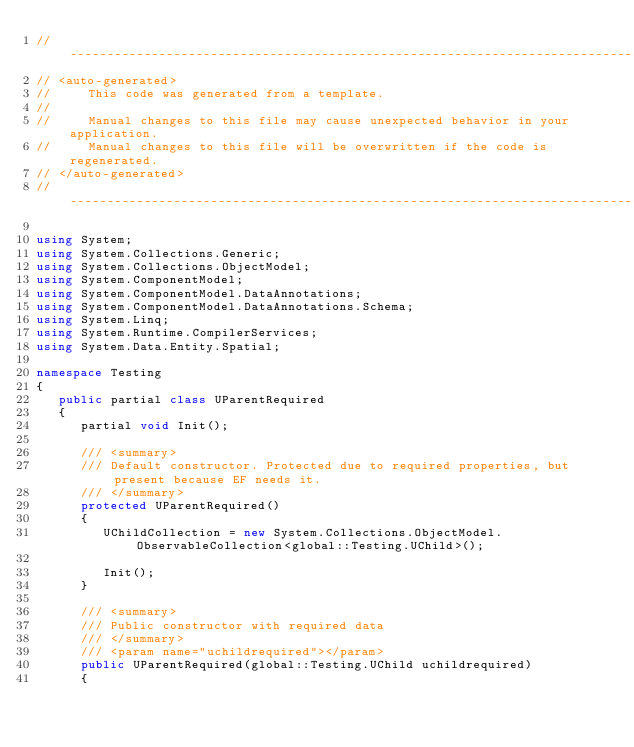<code> <loc_0><loc_0><loc_500><loc_500><_C#_>//------------------------------------------------------------------------------
// <auto-generated>
//     This code was generated from a template.
//
//     Manual changes to this file may cause unexpected behavior in your application.
//     Manual changes to this file will be overwritten if the code is regenerated.
// </auto-generated>
//------------------------------------------------------------------------------

using System;
using System.Collections.Generic;
using System.Collections.ObjectModel;
using System.ComponentModel;
using System.ComponentModel.DataAnnotations;
using System.ComponentModel.DataAnnotations.Schema;
using System.Linq;
using System.Runtime.CompilerServices;
using System.Data.Entity.Spatial;

namespace Testing
{
   public partial class UParentRequired
   {
      partial void Init();

      /// <summary>
      /// Default constructor. Protected due to required properties, but present because EF needs it.
      /// </summary>
      protected UParentRequired()
      {
         UChildCollection = new System.Collections.ObjectModel.ObservableCollection<global::Testing.UChild>();

         Init();
      }

      /// <summary>
      /// Public constructor with required data
      /// </summary>
      /// <param name="uchildrequired"></param>
      public UParentRequired(global::Testing.UChild uchildrequired)
      {</code> 